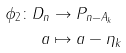<formula> <loc_0><loc_0><loc_500><loc_500>\phi _ { 2 } \colon D _ { n } & \rightarrow P _ { n - A _ { k } } \\ a & \mapsto a - \eta _ { k } \\</formula> 